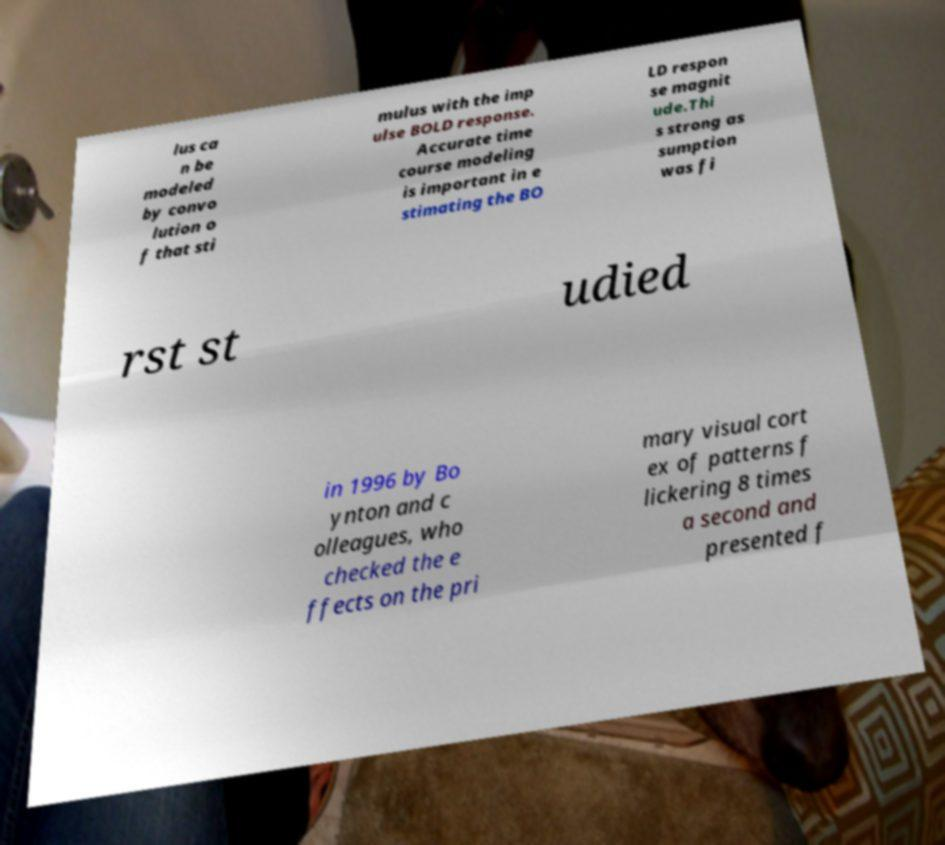Can you read and provide the text displayed in the image?This photo seems to have some interesting text. Can you extract and type it out for me? lus ca n be modeled by convo lution o f that sti mulus with the imp ulse BOLD response. Accurate time course modeling is important in e stimating the BO LD respon se magnit ude.Thi s strong as sumption was fi rst st udied in 1996 by Bo ynton and c olleagues, who checked the e ffects on the pri mary visual cort ex of patterns f lickering 8 times a second and presented f 